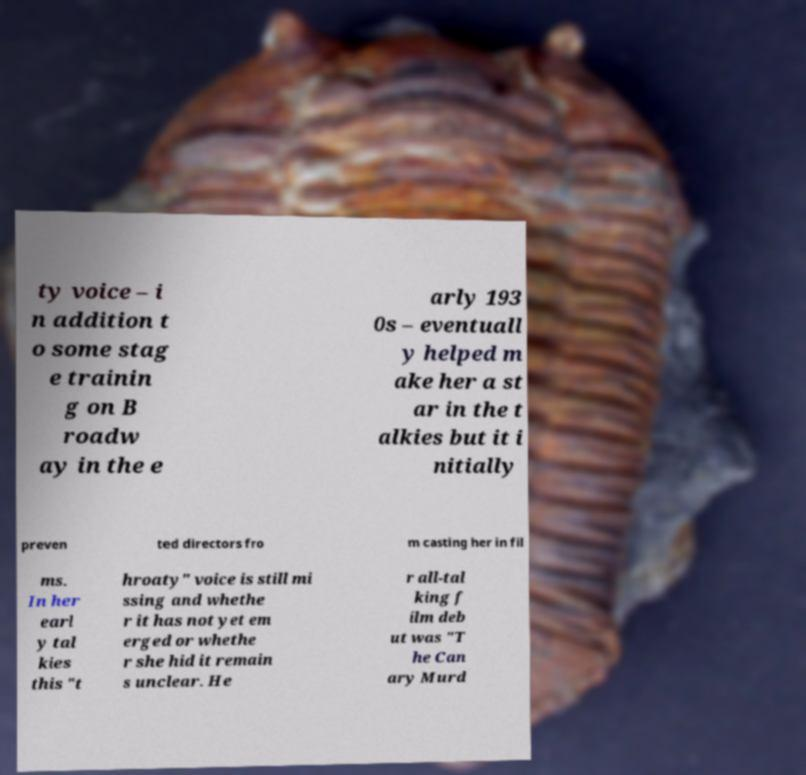Could you extract and type out the text from this image? ty voice – i n addition t o some stag e trainin g on B roadw ay in the e arly 193 0s – eventuall y helped m ake her a st ar in the t alkies but it i nitially preven ted directors fro m casting her in fil ms. In her earl y tal kies this "t hroaty" voice is still mi ssing and whethe r it has not yet em erged or whethe r she hid it remain s unclear. He r all-tal king f ilm deb ut was "T he Can ary Murd 